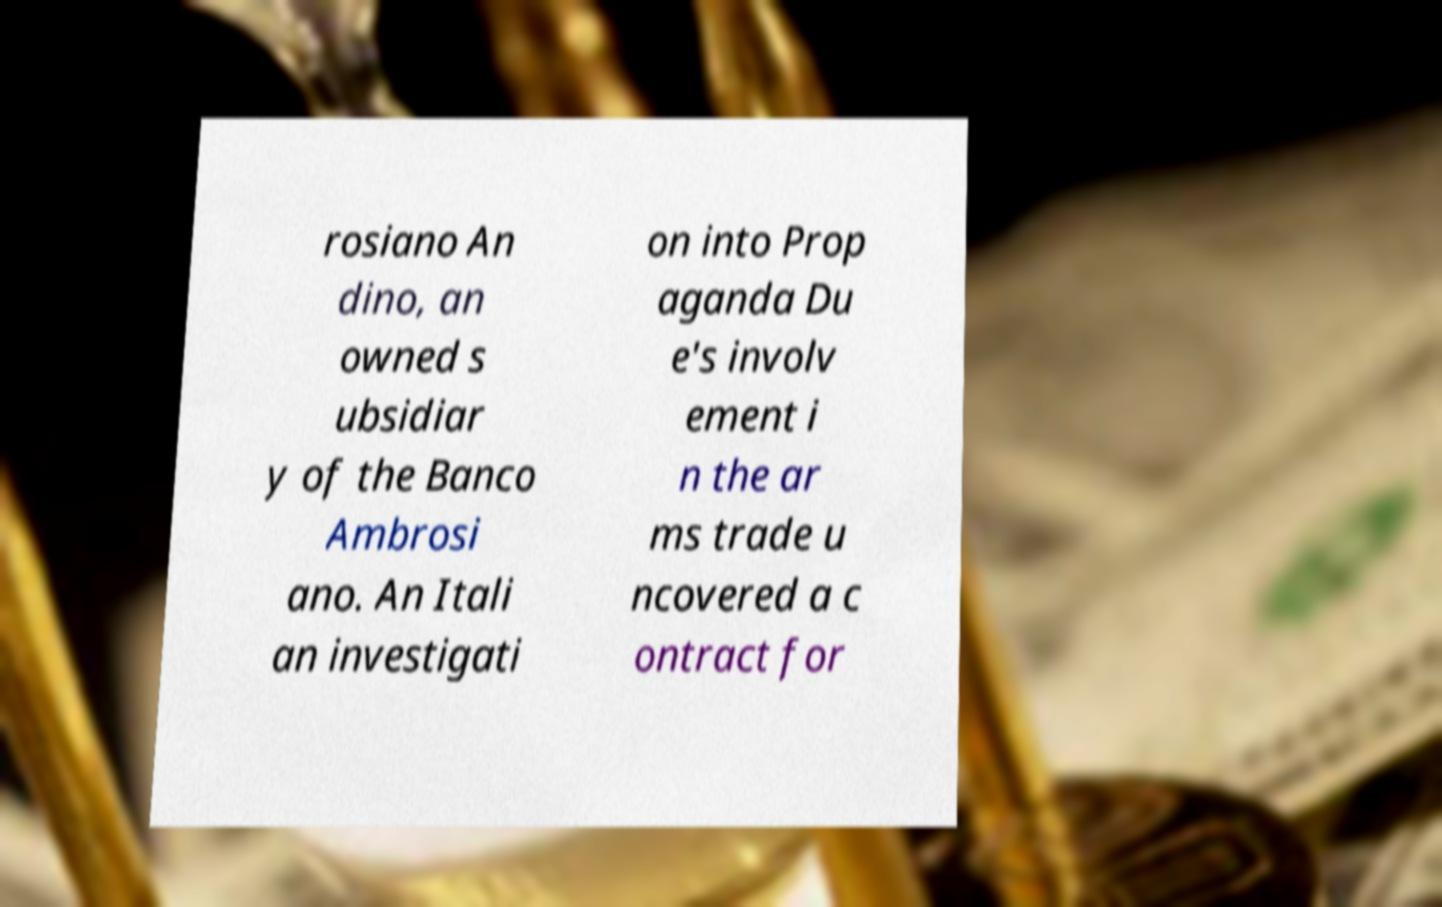Can you accurately transcribe the text from the provided image for me? rosiano An dino, an owned s ubsidiar y of the Banco Ambrosi ano. An Itali an investigati on into Prop aganda Du e's involv ement i n the ar ms trade u ncovered a c ontract for 